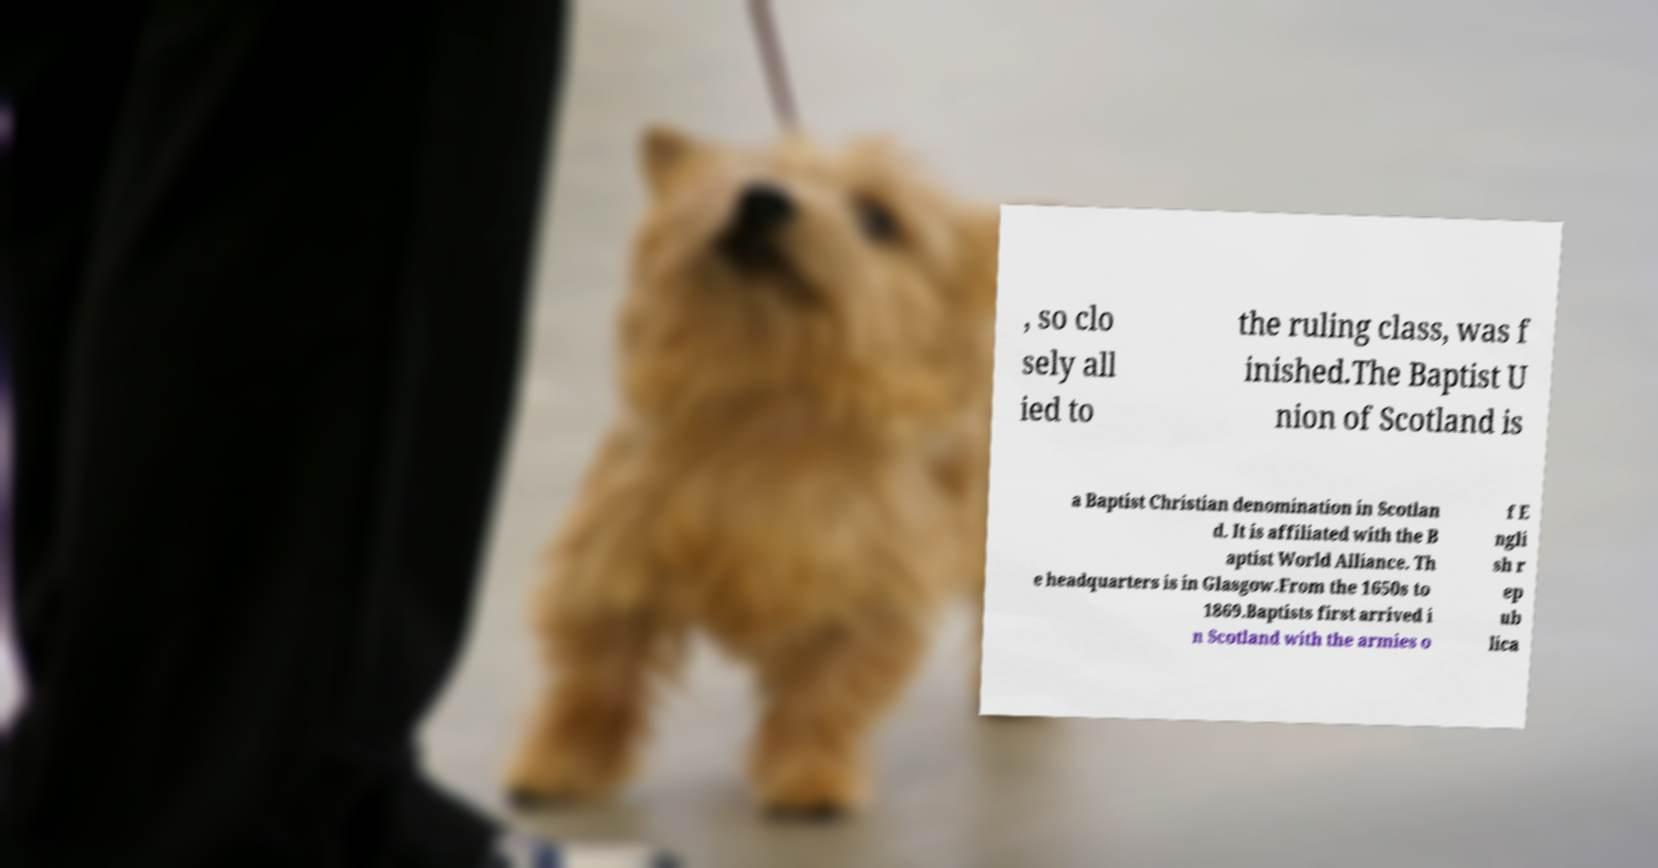Could you assist in decoding the text presented in this image and type it out clearly? , so clo sely all ied to the ruling class, was f inished.The Baptist U nion of Scotland is a Baptist Christian denomination in Scotlan d. It is affiliated with the B aptist World Alliance. Th e headquarters is in Glasgow.From the 1650s to 1869.Baptists first arrived i n Scotland with the armies o f E ngli sh r ep ub lica 